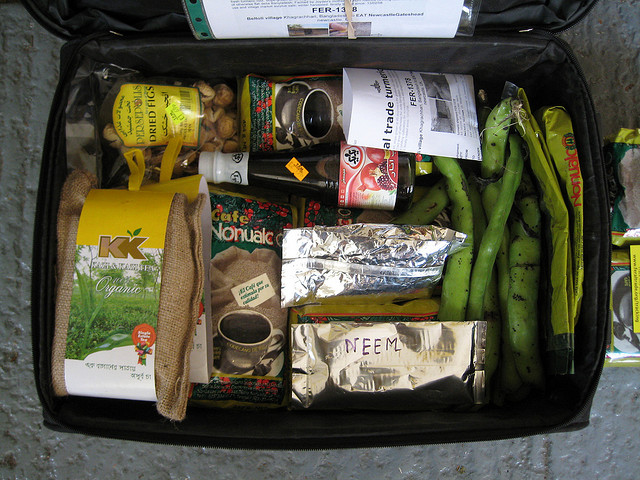Please transcribe the text in this image. Nonualc trade FER- -1 3 8 KK FAR-RSTE turmes al Cafe NEEM Organic DRIED HGS 